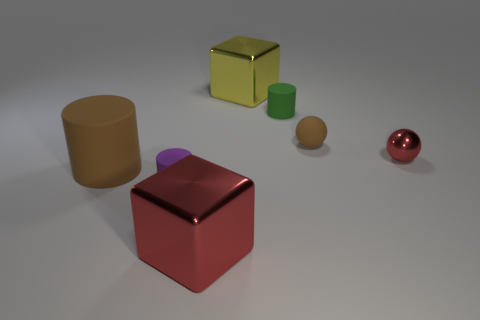What number of things are brown rubber things that are left of the small green rubber thing or large objects in front of the small metallic object?
Offer a very short reply. 2. What number of rubber cylinders are behind the metal thing that is in front of the brown cylinder?
Give a very brief answer. 3. What is the color of the other large block that is the same material as the big yellow block?
Your response must be concise. Red. Is there a gray matte cylinder that has the same size as the yellow metal block?
Provide a succinct answer. No. What shape is the red metal thing that is the same size as the purple matte object?
Your answer should be very brief. Sphere. Are there any purple objects that have the same shape as the yellow object?
Give a very brief answer. No. Does the tiny purple cylinder have the same material as the cube that is behind the green cylinder?
Make the answer very short. No. Is there a big rubber cylinder of the same color as the tiny shiny sphere?
Offer a terse response. No. What number of other objects are there of the same material as the tiny purple thing?
Ensure brevity in your answer.  3. Does the big matte thing have the same color as the tiny matte cylinder left of the large red block?
Your answer should be compact. No. 